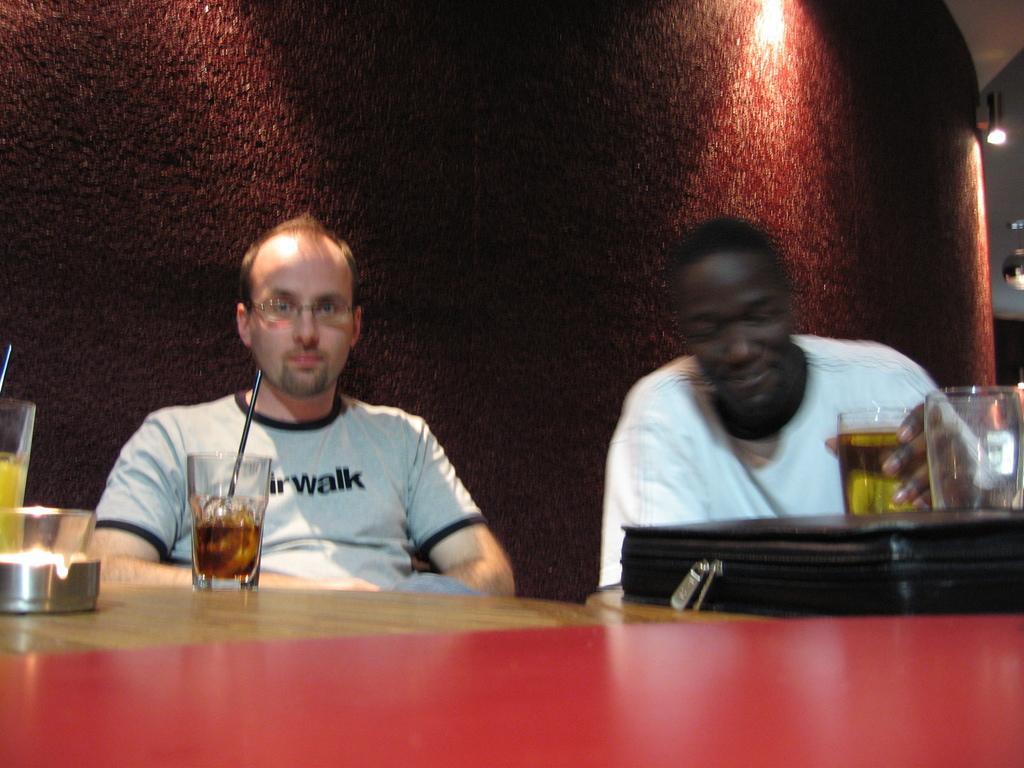Could you give a brief overview of what you see in this image? In this image i can see two men sitting there are few glass , a bag on the table , at the back ground i can a wall and a light. 